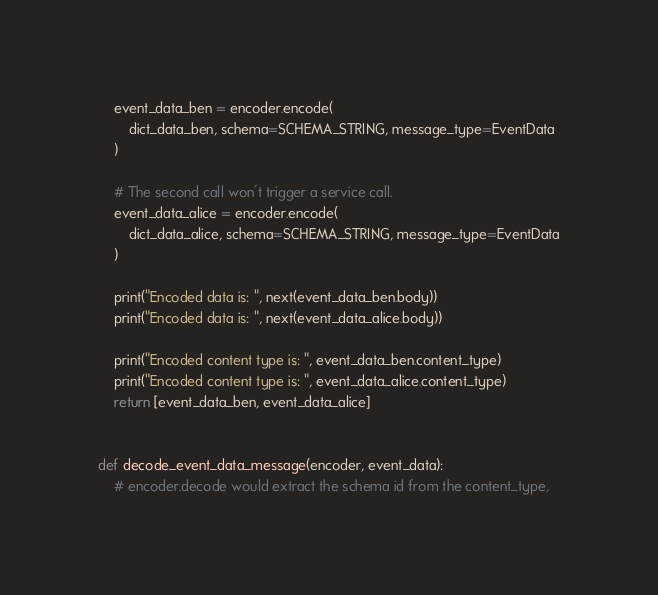Convert code to text. <code><loc_0><loc_0><loc_500><loc_500><_Python_>    event_data_ben = encoder.encode(
        dict_data_ben, schema=SCHEMA_STRING, message_type=EventData
    )

    # The second call won't trigger a service call.
    event_data_alice = encoder.encode(
        dict_data_alice, schema=SCHEMA_STRING, message_type=EventData
    )

    print("Encoded data is: ", next(event_data_ben.body))
    print("Encoded data is: ", next(event_data_alice.body))

    print("Encoded content type is: ", event_data_ben.content_type)
    print("Encoded content type is: ", event_data_alice.content_type)
    return [event_data_ben, event_data_alice]


def decode_event_data_message(encoder, event_data):
    # encoder.decode would extract the schema id from the content_type,</code> 